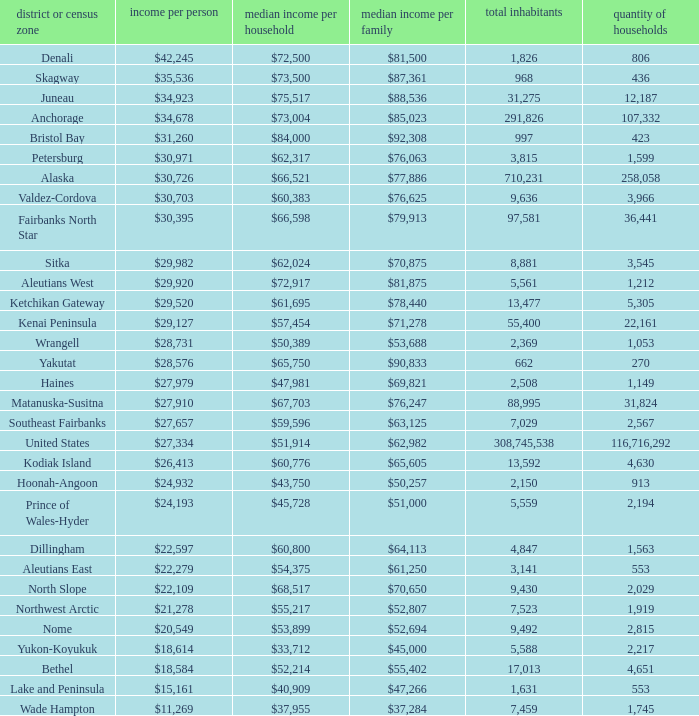What is the population of the area with a median family income of $71,278? 1.0. 